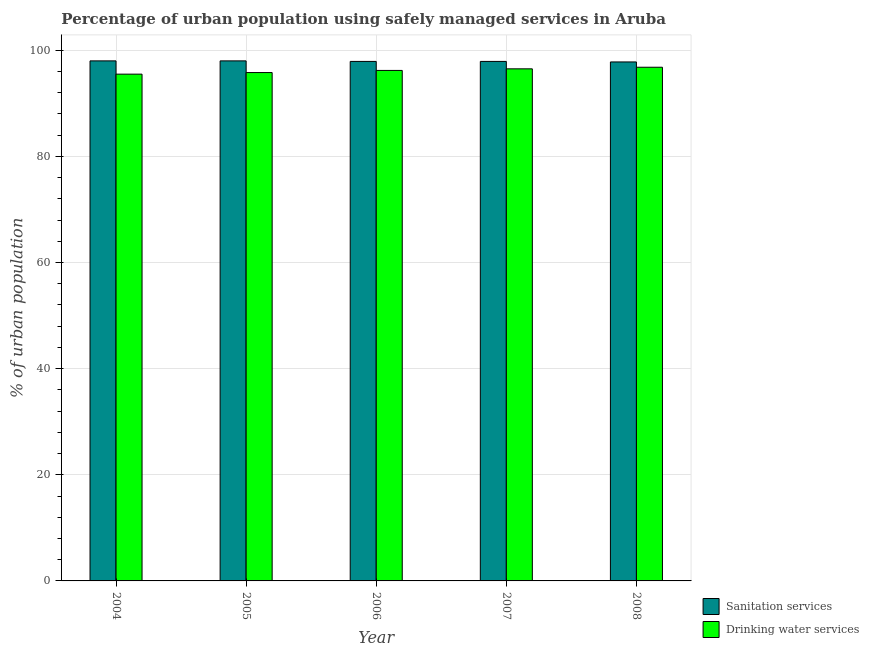How many different coloured bars are there?
Your answer should be very brief. 2. How many bars are there on the 2nd tick from the left?
Provide a succinct answer. 2. What is the percentage of urban population who used sanitation services in 2004?
Offer a terse response. 98. Across all years, what is the maximum percentage of urban population who used drinking water services?
Provide a succinct answer. 96.8. Across all years, what is the minimum percentage of urban population who used drinking water services?
Provide a succinct answer. 95.5. In which year was the percentage of urban population who used sanitation services maximum?
Ensure brevity in your answer.  2004. In which year was the percentage of urban population who used sanitation services minimum?
Your response must be concise. 2008. What is the total percentage of urban population who used sanitation services in the graph?
Offer a terse response. 489.6. What is the difference between the percentage of urban population who used drinking water services in 2006 and that in 2007?
Provide a succinct answer. -0.3. What is the difference between the percentage of urban population who used drinking water services in 2005 and the percentage of urban population who used sanitation services in 2004?
Your response must be concise. 0.3. What is the average percentage of urban population who used drinking water services per year?
Offer a terse response. 96.16. In how many years, is the percentage of urban population who used drinking water services greater than 4 %?
Your response must be concise. 5. What is the ratio of the percentage of urban population who used drinking water services in 2004 to that in 2005?
Your answer should be very brief. 1. Is the percentage of urban population who used sanitation services in 2005 less than that in 2008?
Make the answer very short. No. What is the difference between the highest and the lowest percentage of urban population who used drinking water services?
Keep it short and to the point. 1.3. In how many years, is the percentage of urban population who used drinking water services greater than the average percentage of urban population who used drinking water services taken over all years?
Make the answer very short. 3. What does the 1st bar from the left in 2007 represents?
Offer a terse response. Sanitation services. What does the 1st bar from the right in 2004 represents?
Your answer should be very brief. Drinking water services. Are all the bars in the graph horizontal?
Your answer should be compact. No. What is the difference between two consecutive major ticks on the Y-axis?
Offer a very short reply. 20. Are the values on the major ticks of Y-axis written in scientific E-notation?
Make the answer very short. No. Does the graph contain any zero values?
Your answer should be compact. No. Does the graph contain grids?
Provide a succinct answer. Yes. How many legend labels are there?
Give a very brief answer. 2. How are the legend labels stacked?
Provide a short and direct response. Vertical. What is the title of the graph?
Ensure brevity in your answer.  Percentage of urban population using safely managed services in Aruba. What is the label or title of the X-axis?
Your answer should be compact. Year. What is the label or title of the Y-axis?
Keep it short and to the point. % of urban population. What is the % of urban population of Sanitation services in 2004?
Provide a short and direct response. 98. What is the % of urban population in Drinking water services in 2004?
Provide a short and direct response. 95.5. What is the % of urban population of Sanitation services in 2005?
Your answer should be compact. 98. What is the % of urban population in Drinking water services in 2005?
Keep it short and to the point. 95.8. What is the % of urban population of Sanitation services in 2006?
Provide a short and direct response. 97.9. What is the % of urban population in Drinking water services in 2006?
Provide a succinct answer. 96.2. What is the % of urban population of Sanitation services in 2007?
Offer a very short reply. 97.9. What is the % of urban population of Drinking water services in 2007?
Offer a very short reply. 96.5. What is the % of urban population in Sanitation services in 2008?
Your answer should be very brief. 97.8. What is the % of urban population in Drinking water services in 2008?
Offer a very short reply. 96.8. Across all years, what is the maximum % of urban population in Sanitation services?
Provide a short and direct response. 98. Across all years, what is the maximum % of urban population in Drinking water services?
Ensure brevity in your answer.  96.8. Across all years, what is the minimum % of urban population in Sanitation services?
Offer a very short reply. 97.8. Across all years, what is the minimum % of urban population in Drinking water services?
Provide a short and direct response. 95.5. What is the total % of urban population of Sanitation services in the graph?
Offer a very short reply. 489.6. What is the total % of urban population of Drinking water services in the graph?
Give a very brief answer. 480.8. What is the difference between the % of urban population of Drinking water services in 2004 and that in 2006?
Provide a short and direct response. -0.7. What is the difference between the % of urban population in Sanitation services in 2004 and that in 2007?
Offer a very short reply. 0.1. What is the difference between the % of urban population in Drinking water services in 2004 and that in 2007?
Ensure brevity in your answer.  -1. What is the difference between the % of urban population of Sanitation services in 2004 and that in 2008?
Your response must be concise. 0.2. What is the difference between the % of urban population in Drinking water services in 2004 and that in 2008?
Your answer should be very brief. -1.3. What is the difference between the % of urban population in Sanitation services in 2005 and that in 2006?
Make the answer very short. 0.1. What is the difference between the % of urban population of Drinking water services in 2005 and that in 2006?
Give a very brief answer. -0.4. What is the difference between the % of urban population of Sanitation services in 2005 and that in 2007?
Your response must be concise. 0.1. What is the difference between the % of urban population of Sanitation services in 2005 and that in 2008?
Provide a short and direct response. 0.2. What is the difference between the % of urban population of Sanitation services in 2006 and that in 2008?
Offer a very short reply. 0.1. What is the difference between the % of urban population of Drinking water services in 2006 and that in 2008?
Your response must be concise. -0.6. What is the difference between the % of urban population in Drinking water services in 2007 and that in 2008?
Your answer should be compact. -0.3. What is the difference between the % of urban population in Sanitation services in 2004 and the % of urban population in Drinking water services in 2008?
Your response must be concise. 1.2. What is the difference between the % of urban population in Sanitation services in 2005 and the % of urban population in Drinking water services in 2006?
Keep it short and to the point. 1.8. What is the difference between the % of urban population in Sanitation services in 2005 and the % of urban population in Drinking water services in 2007?
Your answer should be compact. 1.5. What is the difference between the % of urban population in Sanitation services in 2006 and the % of urban population in Drinking water services in 2007?
Your response must be concise. 1.4. What is the difference between the % of urban population in Sanitation services in 2007 and the % of urban population in Drinking water services in 2008?
Keep it short and to the point. 1.1. What is the average % of urban population in Sanitation services per year?
Your response must be concise. 97.92. What is the average % of urban population of Drinking water services per year?
Your answer should be very brief. 96.16. In the year 2005, what is the difference between the % of urban population of Sanitation services and % of urban population of Drinking water services?
Provide a succinct answer. 2.2. In the year 2006, what is the difference between the % of urban population of Sanitation services and % of urban population of Drinking water services?
Keep it short and to the point. 1.7. What is the ratio of the % of urban population in Sanitation services in 2004 to that in 2005?
Ensure brevity in your answer.  1. What is the ratio of the % of urban population in Sanitation services in 2004 to that in 2007?
Offer a terse response. 1. What is the ratio of the % of urban population of Sanitation services in 2004 to that in 2008?
Provide a short and direct response. 1. What is the ratio of the % of urban population in Drinking water services in 2004 to that in 2008?
Provide a succinct answer. 0.99. What is the ratio of the % of urban population of Sanitation services in 2005 to that in 2006?
Make the answer very short. 1. What is the ratio of the % of urban population in Drinking water services in 2005 to that in 2006?
Offer a very short reply. 1. What is the ratio of the % of urban population of Sanitation services in 2005 to that in 2007?
Your answer should be very brief. 1. What is the ratio of the % of urban population in Drinking water services in 2005 to that in 2007?
Make the answer very short. 0.99. What is the ratio of the % of urban population in Sanitation services in 2005 to that in 2008?
Ensure brevity in your answer.  1. What is the ratio of the % of urban population in Sanitation services in 2006 to that in 2007?
Your answer should be very brief. 1. What is the ratio of the % of urban population in Sanitation services in 2006 to that in 2008?
Offer a terse response. 1. What is the ratio of the % of urban population of Drinking water services in 2006 to that in 2008?
Your answer should be very brief. 0.99. What is the ratio of the % of urban population of Sanitation services in 2007 to that in 2008?
Offer a very short reply. 1. What is the ratio of the % of urban population in Drinking water services in 2007 to that in 2008?
Keep it short and to the point. 1. What is the difference between the highest and the second highest % of urban population in Sanitation services?
Keep it short and to the point. 0. What is the difference between the highest and the second highest % of urban population in Drinking water services?
Offer a very short reply. 0.3. What is the difference between the highest and the lowest % of urban population in Drinking water services?
Provide a succinct answer. 1.3. 